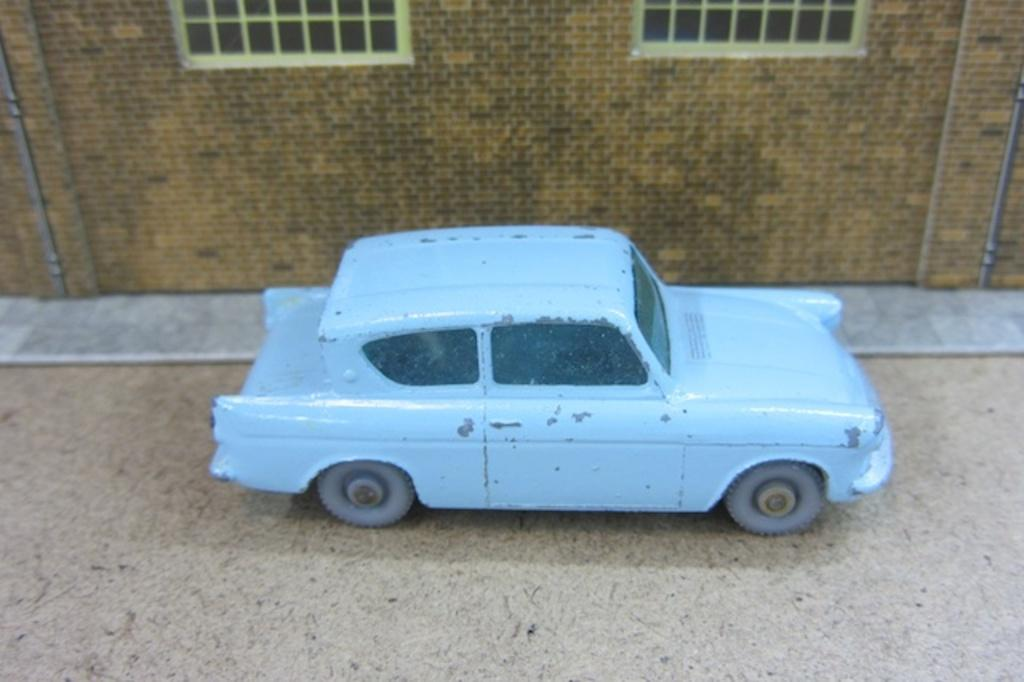What is the main subject in the middle of the image? There is a toy car in the middle of the image. What can be observed about the toy car's location? The toy car is on a surface. What other toy can be seen in the background of the image? There is a toy house in the background of the image. What features does the toy house have? The toy house has a wall and windows. What is the tendency of the crayons in the image? There are no crayons present in the image. Is there a cave visible in the image? No, there is no cave visible in the image. 